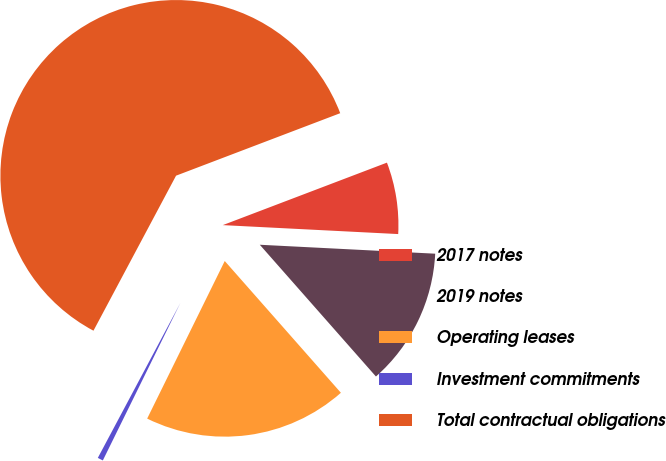Convert chart. <chart><loc_0><loc_0><loc_500><loc_500><pie_chart><fcel>2017 notes<fcel>2019 notes<fcel>Operating leases<fcel>Investment commitments<fcel>Total contractual obligations<nl><fcel>6.6%<fcel>12.69%<fcel>18.78%<fcel>0.51%<fcel>61.42%<nl></chart> 